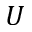<formula> <loc_0><loc_0><loc_500><loc_500>U</formula> 